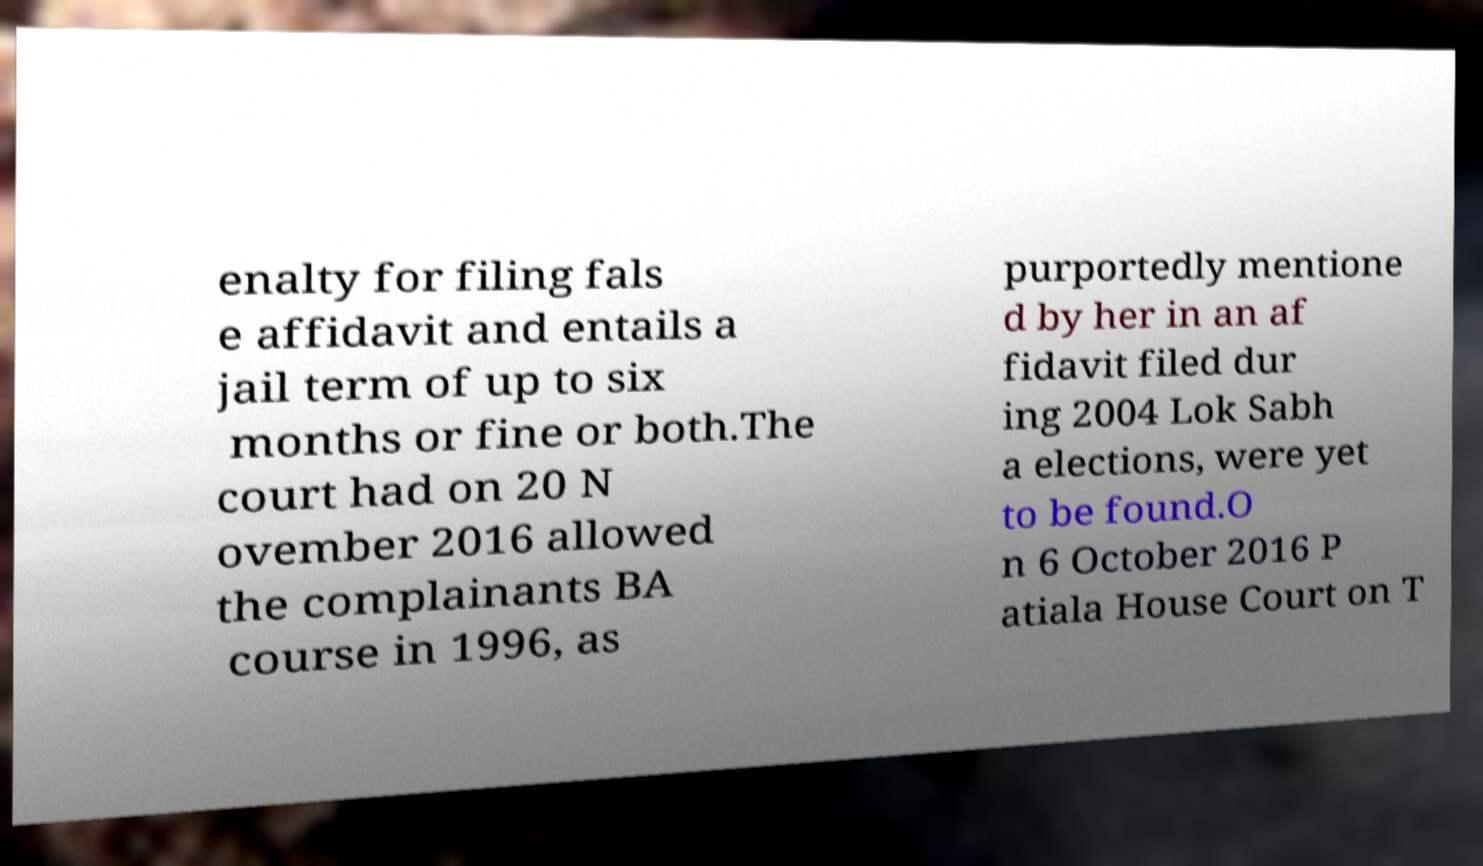Could you assist in decoding the text presented in this image and type it out clearly? enalty for filing fals e affidavit and entails a jail term of up to six months or fine or both.The court had on 20 N ovember 2016 allowed the complainants BA course in 1996, as purportedly mentione d by her in an af fidavit filed dur ing 2004 Lok Sabh a elections, were yet to be found.O n 6 October 2016 P atiala House Court on T 